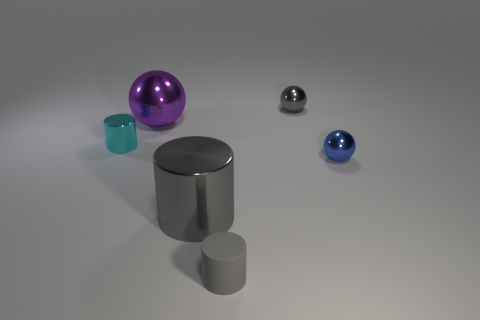What can the different reflections on the objects tell us about their environment? The reflections on the objects suggest a relatively simple environment, with no complex structures visible in the reflections. This indicates the objects are likely placed in an open space with minimal surroundings that could be reflected. 